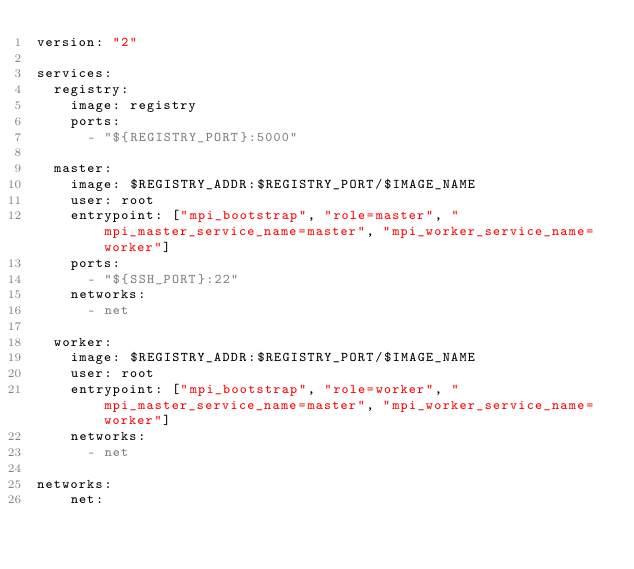<code> <loc_0><loc_0><loc_500><loc_500><_YAML_>version: "2"

services:
  registry:
    image: registry
    ports:
      - "${REGISTRY_PORT}:5000"

  master:
    image: $REGISTRY_ADDR:$REGISTRY_PORT/$IMAGE_NAME
    user: root
    entrypoint: ["mpi_bootstrap", "role=master", "mpi_master_service_name=master", "mpi_worker_service_name=worker"]
    ports:
      - "${SSH_PORT}:22"
    networks:
      - net

  worker:
    image: $REGISTRY_ADDR:$REGISTRY_PORT/$IMAGE_NAME
    user: root
    entrypoint: ["mpi_bootstrap", "role=worker", "mpi_master_service_name=master", "mpi_worker_service_name=worker"]
    networks:
      - net

networks:
    net:
</code> 